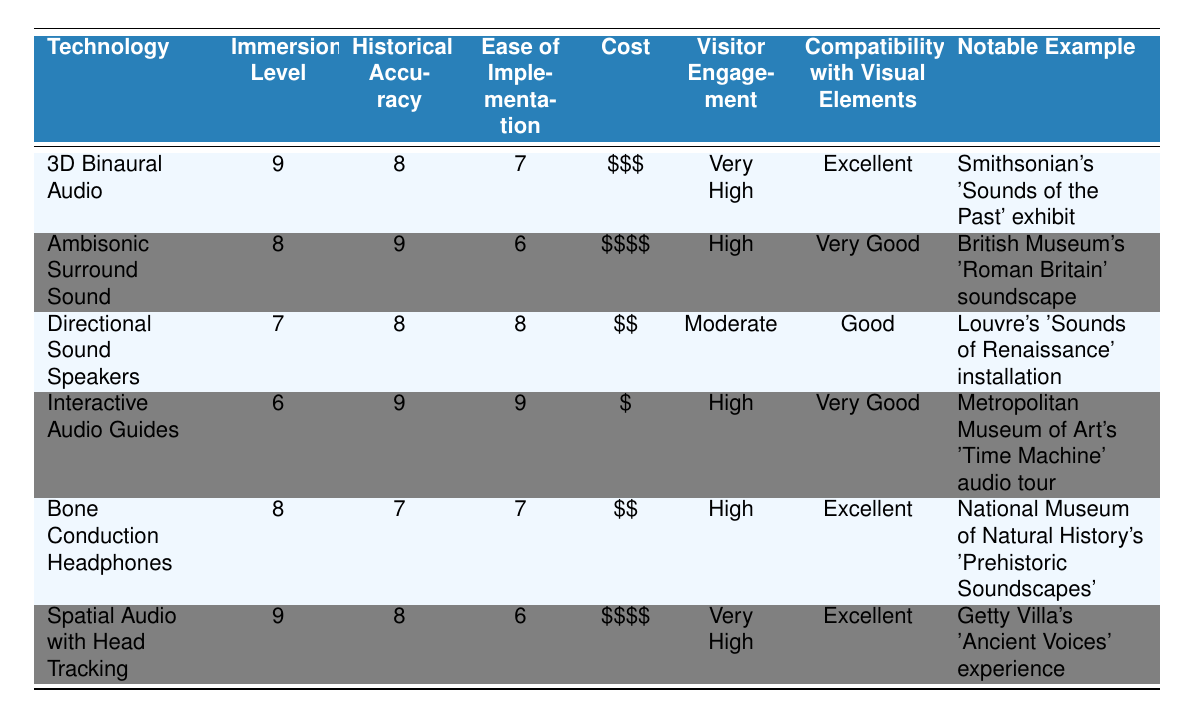What is the highest immersion level among the audio technologies? The immersion levels are listed in the table: 9 for 3D Binaural Audio and Spatial Audio with Head Tracking. Both technologies have the same high level, thus the highest immersion level is 9.
Answer: 9 Which audio technology offers the best compatibility with visual elements? The data shows that 3D Binaural Audio and Spatial Audio with Head Tracking both have "Excellent" compatibility with visual elements, making them the top choices in this category.
Answer: Excellent How many audio technologies have a historical accuracy rating of 8 or higher? The table mentions four audio technologies that have a historical accuracy rating of 8 or higher: 3D Binaural Audio, Ambisonic Surround Sound, Directional Sound Speakers, and Spatial Audio with Head Tracking. This adds up to four technologies.
Answer: 4 Which audio technology has the lowest visitor engagement? By comparing the visitor engagement ratings, Directional Sound Speakers have "Moderate" visitor engagement which is lower than the other technologies that have "High" or "Very High." Therefore, it ranks lowest in this category.
Answer: Directional Sound Speakers What is the average ease of implementation for all listed audio technologies? To find the average ease of implementation, we sum the ease ratings: 7 + 6 + 8 + 9 + 7 + 6 = 43. There are six technologies, therefore the average becomes 43 / 6 = 7.17.
Answer: 7.17 Is the cost of Ambisonic Surround Sound higher than that of Interactive Audio Guides? Ambisonic Surround Sound has a cost rating of "$$$$" while Interactive Audio Guides costs "$". Since "$$$$" indicates a higher expense than "$", the statement is true.
Answer: Yes Which audio technology with the highest historical accuracy also has very high visitor engagement? The technologies with historical accuracy of 9 are Interactive Audio Guides and Ambisonic Surround Sound. However, only Interactive Audio Guides have "High" visitor engagement, whereas Ambisonic Surround Sound has "High" as well. Therefore, none have "Very High". The other high historical accuracy (Ambisonic Surround Sound) does not meet the engagement requirement.
Answer: None How does the immersion level of Bone Conduction Headphones compare to Directional Sound Speakers? Bone Conduction Headphones have an immersion level of 8, while Directional Sound Speakers have a level of 7. Thus, Bone Conduction Headphones have a higher immersion level by 1 point.
Answer: Bone Conduction Headphones are higher 